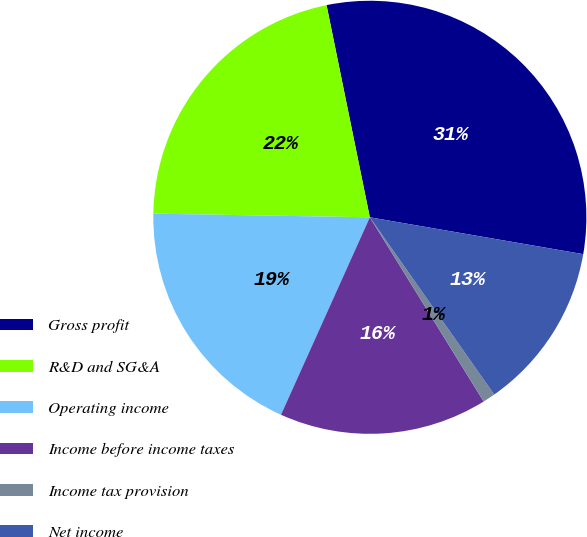Convert chart to OTSL. <chart><loc_0><loc_0><loc_500><loc_500><pie_chart><fcel>Gross profit<fcel>R&D and SG&A<fcel>Operating income<fcel>Income before income taxes<fcel>Income tax provision<fcel>Net income<nl><fcel>30.93%<fcel>21.53%<fcel>18.54%<fcel>15.54%<fcel>0.93%<fcel>12.54%<nl></chart> 